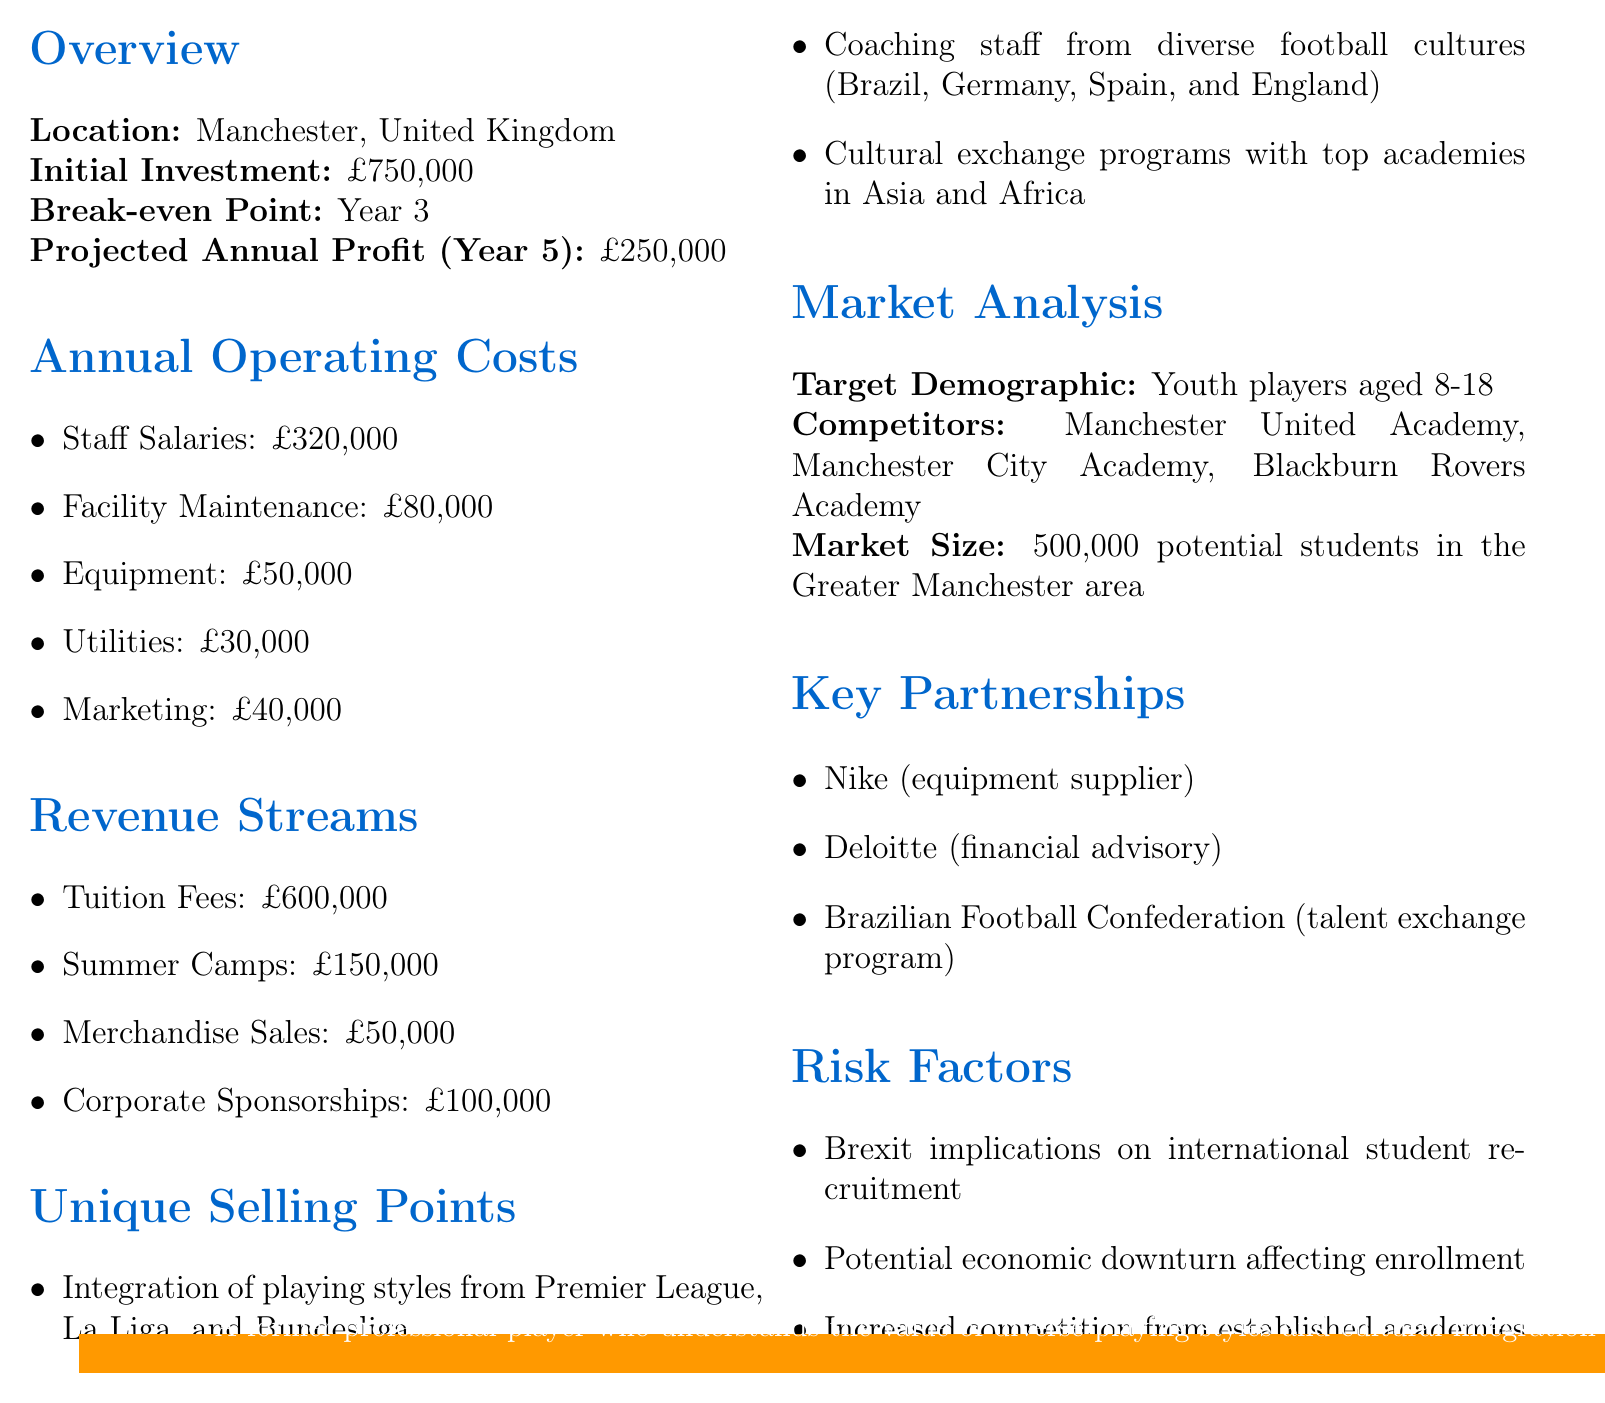What is the initial investment required? The initial investment is stated clearly in the document as a monetary value.
Answer: £750,000 What are the annual operating costs for staff salaries? The document lists individual costs, and the staff salaries are specified.
Answer: £320,000 What is the projected annual profit in year 5? The document provides a specific financial projection for the fifth year.
Answer: £250,000 What unique selling point emphasizes cultural diversity? The unique selling points include features that highlight various cultural integrations and coaching styles.
Answer: Cultural exchange programs with top academies in Asia and Africa What is the target demographic for the academy? The document identifies the specific age range of youth players being targeted for enrollment.
Answer: Youth players aged 8-18 When is the break-even point projected to be? The financial report outlines a specific year for achieving break-even status.
Answer: Year 3 Which company is listed as an equipment supplier? The document indicates key partnerships, including names of specific companies tied to the academy's operations.
Answer: Nike What economic factor is listed as a risk? Several risk factors are identified, including external economic influences that could impact the academy.
Answer: Potential economic downturn affecting enrollment 